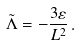Convert formula to latex. <formula><loc_0><loc_0><loc_500><loc_500>\tilde { \Lambda } = - \frac { 3 \varepsilon } { L ^ { 2 } } \, .</formula> 